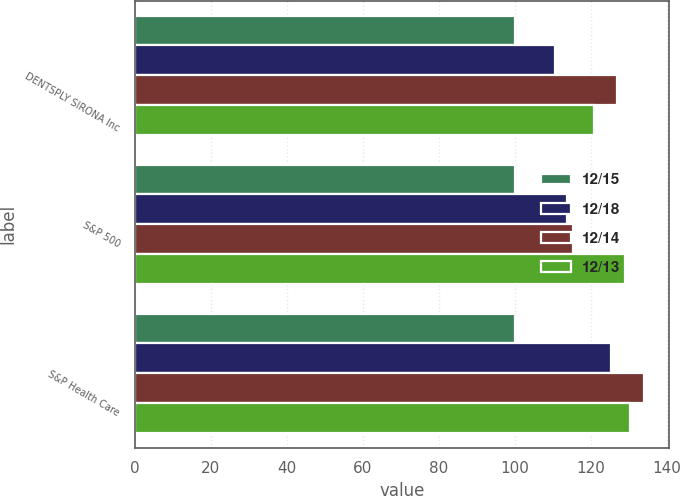Convert chart to OTSL. <chart><loc_0><loc_0><loc_500><loc_500><stacked_bar_chart><ecel><fcel>DENTSPLY SIRONA Inc<fcel>S&P 500<fcel>S&P Health Care<nl><fcel>12/15<fcel>100<fcel>100<fcel>100<nl><fcel>12/18<fcel>110.49<fcel>113.69<fcel>125.34<nl><fcel>12/14<fcel>126.89<fcel>115.26<fcel>133.97<nl><fcel>12/13<fcel>121<fcel>129.05<fcel>130.37<nl></chart> 